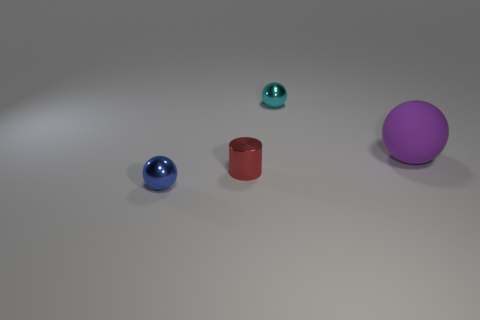How many other shiny cylinders are the same size as the cylinder?
Make the answer very short. 0. Are there fewer purple objects behind the purple thing than tiny metallic things that are behind the red metal cylinder?
Your answer should be compact. Yes. What number of shiny objects are yellow cylinders or tiny red things?
Provide a short and direct response. 1. The cyan shiny thing is what shape?
Your answer should be compact. Sphere. There is a cyan ball that is the same size as the cylinder; what material is it?
Give a very brief answer. Metal. How many small things are purple objects or cyan metal objects?
Make the answer very short. 1. Are there any small purple rubber cylinders?
Your response must be concise. No. The blue object that is made of the same material as the red cylinder is what size?
Offer a very short reply. Small. Is the tiny cyan object made of the same material as the purple object?
Offer a very short reply. No. How many other things are there of the same material as the cyan thing?
Offer a terse response. 2. 